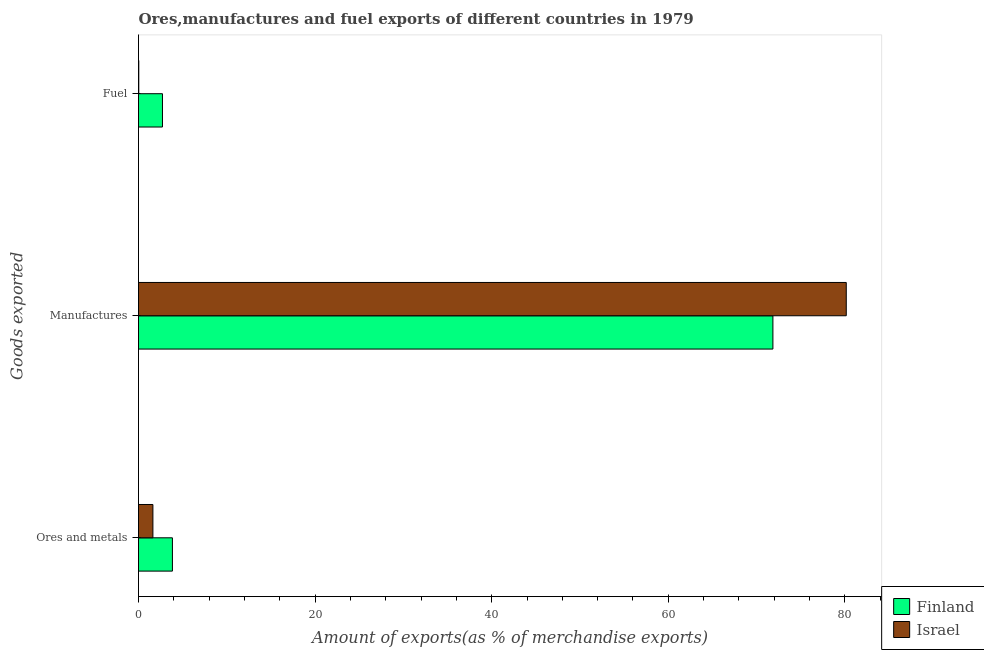Are the number of bars per tick equal to the number of legend labels?
Your answer should be very brief. Yes. Are the number of bars on each tick of the Y-axis equal?
Your answer should be compact. Yes. How many bars are there on the 1st tick from the bottom?
Your answer should be very brief. 2. What is the label of the 3rd group of bars from the top?
Provide a succinct answer. Ores and metals. What is the percentage of manufactures exports in Finland?
Provide a succinct answer. 71.85. Across all countries, what is the maximum percentage of fuel exports?
Provide a succinct answer. 2.71. Across all countries, what is the minimum percentage of manufactures exports?
Keep it short and to the point. 71.85. What is the total percentage of ores and metals exports in the graph?
Give a very brief answer. 5.47. What is the difference between the percentage of fuel exports in Israel and that in Finland?
Offer a terse response. -2.68. What is the difference between the percentage of fuel exports in Finland and the percentage of ores and metals exports in Israel?
Provide a succinct answer. 1.08. What is the average percentage of manufactures exports per country?
Give a very brief answer. 76.01. What is the difference between the percentage of manufactures exports and percentage of ores and metals exports in Finland?
Offer a very short reply. 68.01. What is the ratio of the percentage of ores and metals exports in Israel to that in Finland?
Ensure brevity in your answer.  0.42. Is the difference between the percentage of manufactures exports in Finland and Israel greater than the difference between the percentage of fuel exports in Finland and Israel?
Offer a very short reply. No. What is the difference between the highest and the second highest percentage of manufactures exports?
Your response must be concise. 8.31. What is the difference between the highest and the lowest percentage of fuel exports?
Your response must be concise. 2.68. What does the 1st bar from the top in Ores and metals represents?
Give a very brief answer. Israel. What does the 1st bar from the bottom in Ores and metals represents?
Your answer should be compact. Finland. Is it the case that in every country, the sum of the percentage of ores and metals exports and percentage of manufactures exports is greater than the percentage of fuel exports?
Make the answer very short. Yes. How many bars are there?
Your answer should be compact. 6. Are all the bars in the graph horizontal?
Ensure brevity in your answer.  Yes. What is the difference between two consecutive major ticks on the X-axis?
Offer a very short reply. 20. Are the values on the major ticks of X-axis written in scientific E-notation?
Your response must be concise. No. Does the graph contain any zero values?
Give a very brief answer. No. What is the title of the graph?
Keep it short and to the point. Ores,manufactures and fuel exports of different countries in 1979. What is the label or title of the X-axis?
Provide a succinct answer. Amount of exports(as % of merchandise exports). What is the label or title of the Y-axis?
Give a very brief answer. Goods exported. What is the Amount of exports(as % of merchandise exports) in Finland in Ores and metals?
Keep it short and to the point. 3.84. What is the Amount of exports(as % of merchandise exports) in Israel in Ores and metals?
Your answer should be compact. 1.63. What is the Amount of exports(as % of merchandise exports) in Finland in Manufactures?
Provide a short and direct response. 71.85. What is the Amount of exports(as % of merchandise exports) in Israel in Manufactures?
Your response must be concise. 80.16. What is the Amount of exports(as % of merchandise exports) of Finland in Fuel?
Ensure brevity in your answer.  2.71. What is the Amount of exports(as % of merchandise exports) in Israel in Fuel?
Make the answer very short. 0.03. Across all Goods exported, what is the maximum Amount of exports(as % of merchandise exports) of Finland?
Your response must be concise. 71.85. Across all Goods exported, what is the maximum Amount of exports(as % of merchandise exports) of Israel?
Your answer should be very brief. 80.16. Across all Goods exported, what is the minimum Amount of exports(as % of merchandise exports) of Finland?
Offer a very short reply. 2.71. Across all Goods exported, what is the minimum Amount of exports(as % of merchandise exports) in Israel?
Your response must be concise. 0.03. What is the total Amount of exports(as % of merchandise exports) of Finland in the graph?
Your answer should be compact. 78.41. What is the total Amount of exports(as % of merchandise exports) in Israel in the graph?
Give a very brief answer. 81.82. What is the difference between the Amount of exports(as % of merchandise exports) in Finland in Ores and metals and that in Manufactures?
Offer a very short reply. -68.01. What is the difference between the Amount of exports(as % of merchandise exports) in Israel in Ores and metals and that in Manufactures?
Provide a succinct answer. -78.53. What is the difference between the Amount of exports(as % of merchandise exports) of Finland in Ores and metals and that in Fuel?
Ensure brevity in your answer.  1.13. What is the difference between the Amount of exports(as % of merchandise exports) in Israel in Ores and metals and that in Fuel?
Your answer should be very brief. 1.6. What is the difference between the Amount of exports(as % of merchandise exports) of Finland in Manufactures and that in Fuel?
Your answer should be compact. 69.14. What is the difference between the Amount of exports(as % of merchandise exports) in Israel in Manufactures and that in Fuel?
Give a very brief answer. 80.13. What is the difference between the Amount of exports(as % of merchandise exports) of Finland in Ores and metals and the Amount of exports(as % of merchandise exports) of Israel in Manufactures?
Ensure brevity in your answer.  -76.32. What is the difference between the Amount of exports(as % of merchandise exports) of Finland in Ores and metals and the Amount of exports(as % of merchandise exports) of Israel in Fuel?
Make the answer very short. 3.81. What is the difference between the Amount of exports(as % of merchandise exports) of Finland in Manufactures and the Amount of exports(as % of merchandise exports) of Israel in Fuel?
Offer a terse response. 71.82. What is the average Amount of exports(as % of merchandise exports) of Finland per Goods exported?
Ensure brevity in your answer.  26.14. What is the average Amount of exports(as % of merchandise exports) in Israel per Goods exported?
Ensure brevity in your answer.  27.27. What is the difference between the Amount of exports(as % of merchandise exports) of Finland and Amount of exports(as % of merchandise exports) of Israel in Ores and metals?
Provide a short and direct response. 2.21. What is the difference between the Amount of exports(as % of merchandise exports) of Finland and Amount of exports(as % of merchandise exports) of Israel in Manufactures?
Give a very brief answer. -8.31. What is the difference between the Amount of exports(as % of merchandise exports) in Finland and Amount of exports(as % of merchandise exports) in Israel in Fuel?
Your answer should be compact. 2.68. What is the ratio of the Amount of exports(as % of merchandise exports) of Finland in Ores and metals to that in Manufactures?
Provide a succinct answer. 0.05. What is the ratio of the Amount of exports(as % of merchandise exports) of Israel in Ores and metals to that in Manufactures?
Your answer should be compact. 0.02. What is the ratio of the Amount of exports(as % of merchandise exports) of Finland in Ores and metals to that in Fuel?
Provide a succinct answer. 1.42. What is the ratio of the Amount of exports(as % of merchandise exports) of Israel in Ores and metals to that in Fuel?
Offer a terse response. 52.4. What is the ratio of the Amount of exports(as % of merchandise exports) in Finland in Manufactures to that in Fuel?
Your response must be concise. 26.48. What is the ratio of the Amount of exports(as % of merchandise exports) in Israel in Manufactures to that in Fuel?
Provide a short and direct response. 2574.34. What is the difference between the highest and the second highest Amount of exports(as % of merchandise exports) in Finland?
Your answer should be compact. 68.01. What is the difference between the highest and the second highest Amount of exports(as % of merchandise exports) of Israel?
Ensure brevity in your answer.  78.53. What is the difference between the highest and the lowest Amount of exports(as % of merchandise exports) of Finland?
Provide a short and direct response. 69.14. What is the difference between the highest and the lowest Amount of exports(as % of merchandise exports) in Israel?
Make the answer very short. 80.13. 